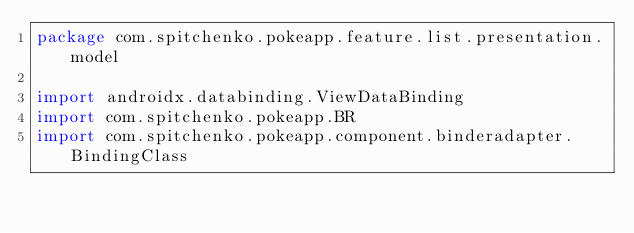<code> <loc_0><loc_0><loc_500><loc_500><_Kotlin_>package com.spitchenko.pokeapp.feature.list.presentation.model

import androidx.databinding.ViewDataBinding
import com.spitchenko.pokeapp.BR
import com.spitchenko.pokeapp.component.binderadapter.BindingClass</code> 